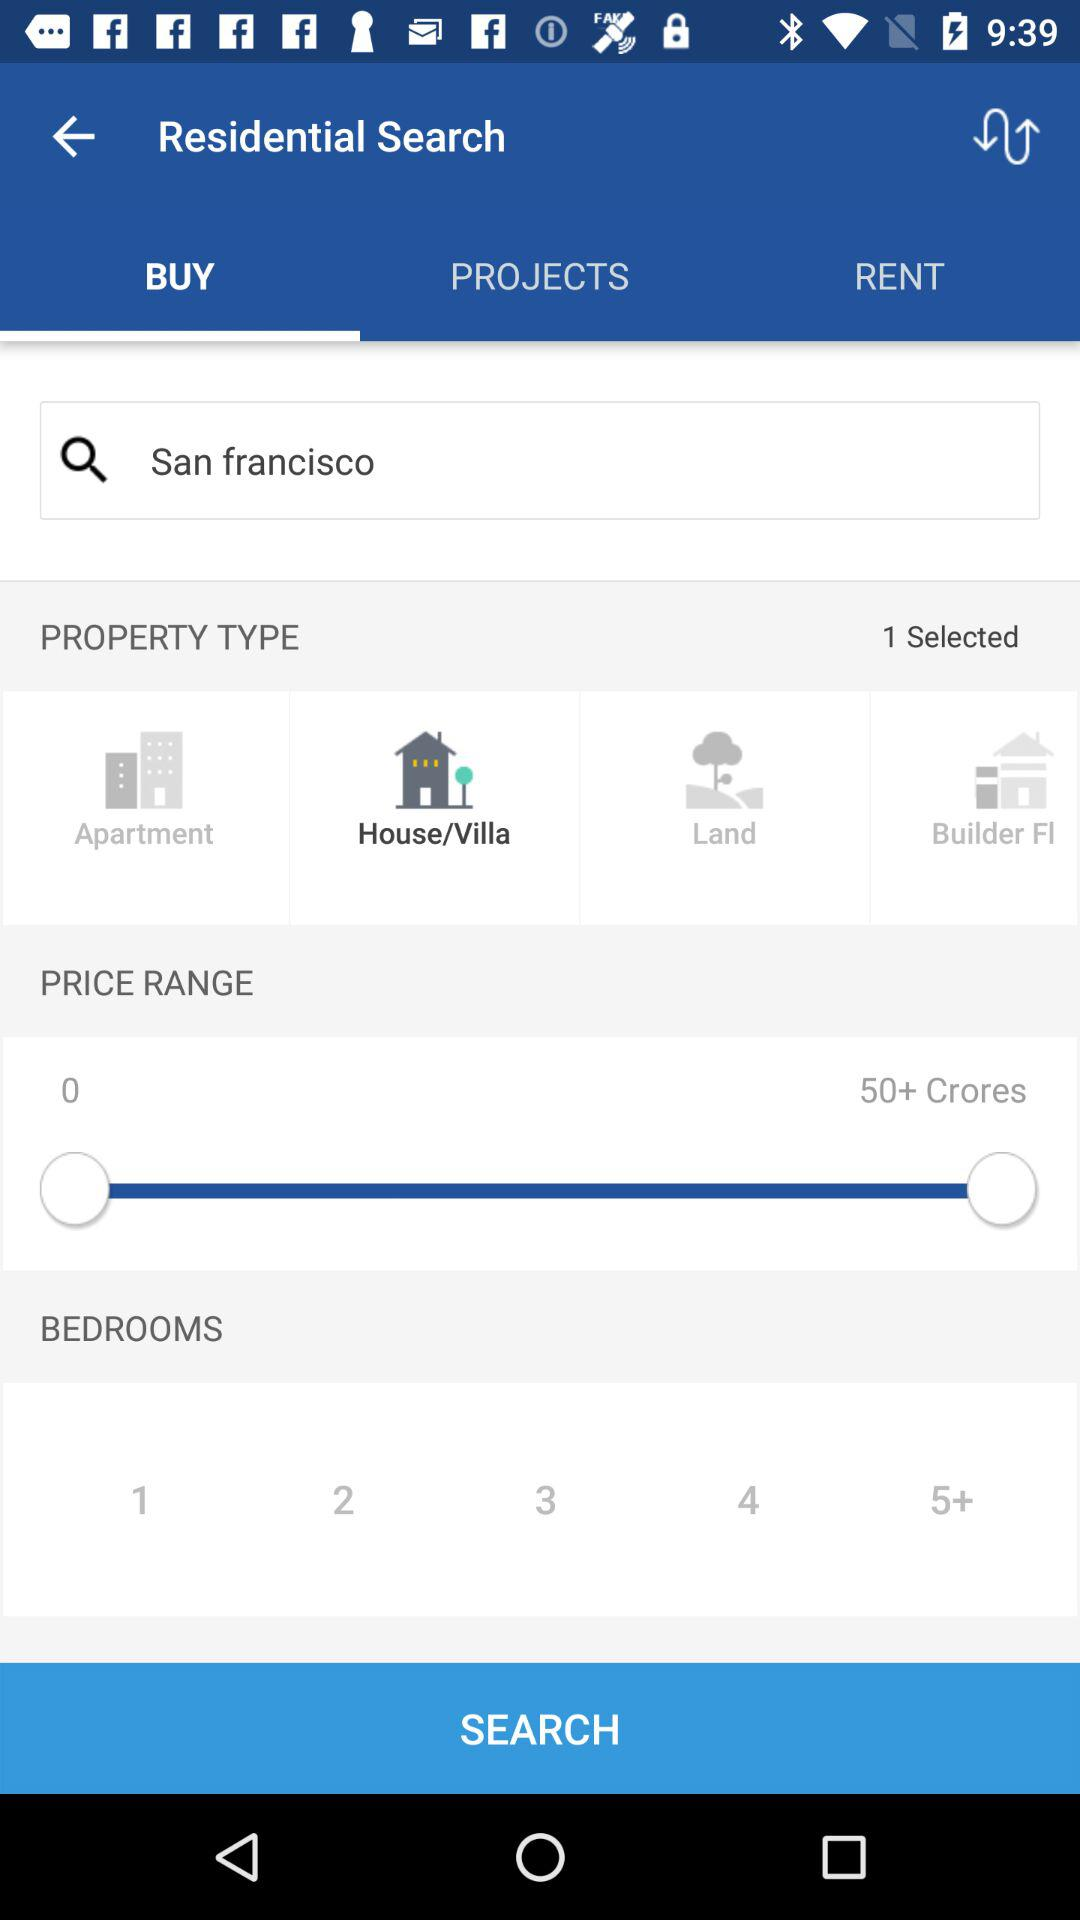How many properties were selected? There was 1 property. 